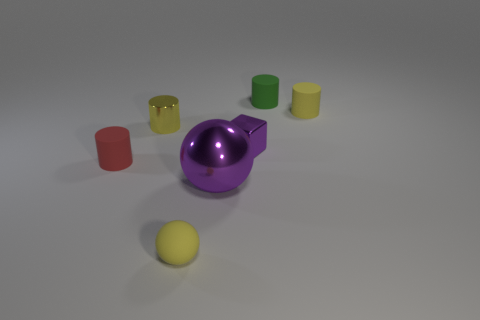There is a small sphere that is the same color as the shiny cylinder; what is it made of?
Provide a succinct answer. Rubber. Are there fewer small rubber cylinders than objects?
Offer a terse response. Yes. What is the color of the other small metallic object that is the same shape as the tiny green thing?
Make the answer very short. Yellow. There is a purple metal thing behind the small rubber cylinder that is on the left side of the small matte ball; are there any small yellow cylinders on the left side of it?
Give a very brief answer. Yes. Is the tiny green object the same shape as the red object?
Keep it short and to the point. Yes. Are there fewer tiny purple cubes that are in front of the small red matte object than brown metal things?
Provide a succinct answer. No. What color is the matte cylinder to the left of the tiny yellow cylinder that is in front of the tiny yellow thing behind the yellow metallic object?
Make the answer very short. Red. What number of shiny objects are either small yellow objects or yellow spheres?
Keep it short and to the point. 1. Do the red matte thing and the purple metallic sphere have the same size?
Give a very brief answer. No. Are there fewer purple metallic things to the left of the small red rubber cylinder than cylinders that are behind the green matte cylinder?
Give a very brief answer. No. 